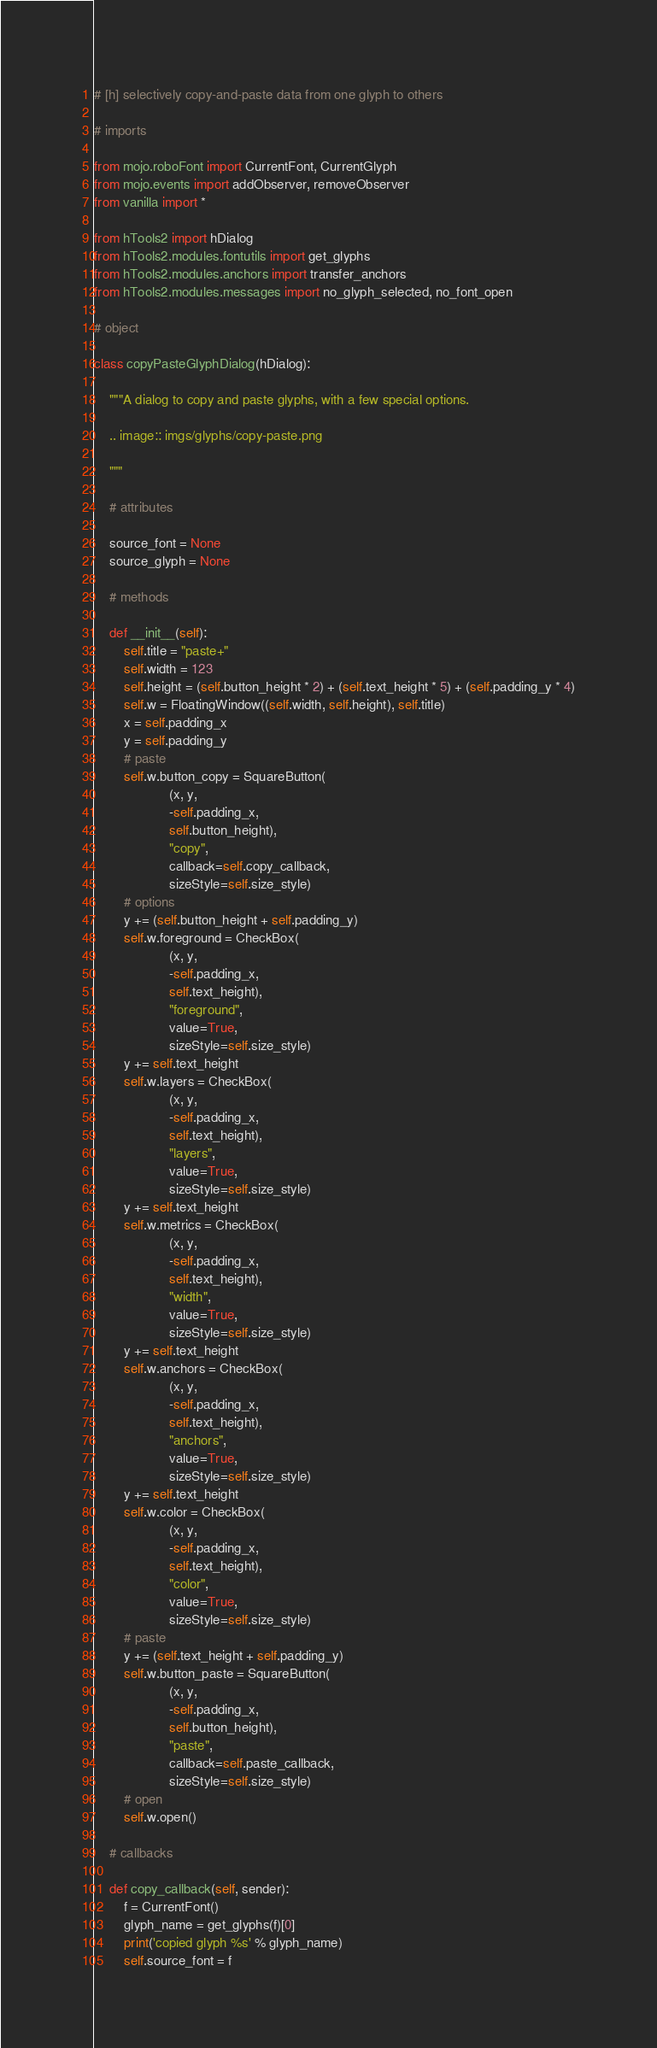<code> <loc_0><loc_0><loc_500><loc_500><_Python_># [h] selectively copy-and-paste data from one glyph to others

# imports

from mojo.roboFont import CurrentFont, CurrentGlyph
from mojo.events import addObserver, removeObserver
from vanilla import *

from hTools2 import hDialog
from hTools2.modules.fontutils import get_glyphs
from hTools2.modules.anchors import transfer_anchors
from hTools2.modules.messages import no_glyph_selected, no_font_open

# object

class copyPasteGlyphDialog(hDialog):

    """A dialog to copy and paste glyphs, with a few special options.

    .. image:: imgs/glyphs/copy-paste.png

    """

    # attributes

    source_font = None
    source_glyph = None

    # methods

    def __init__(self):
        self.title = "paste+"
        self.width = 123
        self.height = (self.button_height * 2) + (self.text_height * 5) + (self.padding_y * 4)
        self.w = FloatingWindow((self.width, self.height), self.title)
        x = self.padding_x
        y = self.padding_y
        # paste
        self.w.button_copy = SquareButton(
                    (x, y,
                    -self.padding_x,
                    self.button_height),
                    "copy",
                    callback=self.copy_callback,
                    sizeStyle=self.size_style)
        # options
        y += (self.button_height + self.padding_y)
        self.w.foreground = CheckBox(
                    (x, y,
                    -self.padding_x,
                    self.text_height),
                    "foreground",
                    value=True,
                    sizeStyle=self.size_style)
        y += self.text_height
        self.w.layers = CheckBox(
                    (x, y,
                    -self.padding_x,
                    self.text_height),
                    "layers",
                    value=True,
                    sizeStyle=self.size_style)
        y += self.text_height
        self.w.metrics = CheckBox(
                    (x, y,
                    -self.padding_x,
                    self.text_height),
                    "width",
                    value=True,
                    sizeStyle=self.size_style)
        y += self.text_height
        self.w.anchors = CheckBox(
                    (x, y,
                    -self.padding_x,
                    self.text_height),
                    "anchors",
                    value=True,
                    sizeStyle=self.size_style)
        y += self.text_height
        self.w.color = CheckBox(
                    (x, y,
                    -self.padding_x,
                    self.text_height),
                    "color",
                    value=True,
                    sizeStyle=self.size_style)
        # paste
        y += (self.text_height + self.padding_y)
        self.w.button_paste = SquareButton(
                    (x, y,
                    -self.padding_x,
                    self.button_height),
                    "paste",
                    callback=self.paste_callback,
                    sizeStyle=self.size_style)
        # open
        self.w.open()

    # callbacks

    def copy_callback(self, sender):
        f = CurrentFont()
        glyph_name = get_glyphs(f)[0]
        print('copied glyph %s' % glyph_name)
        self.source_font = f</code> 